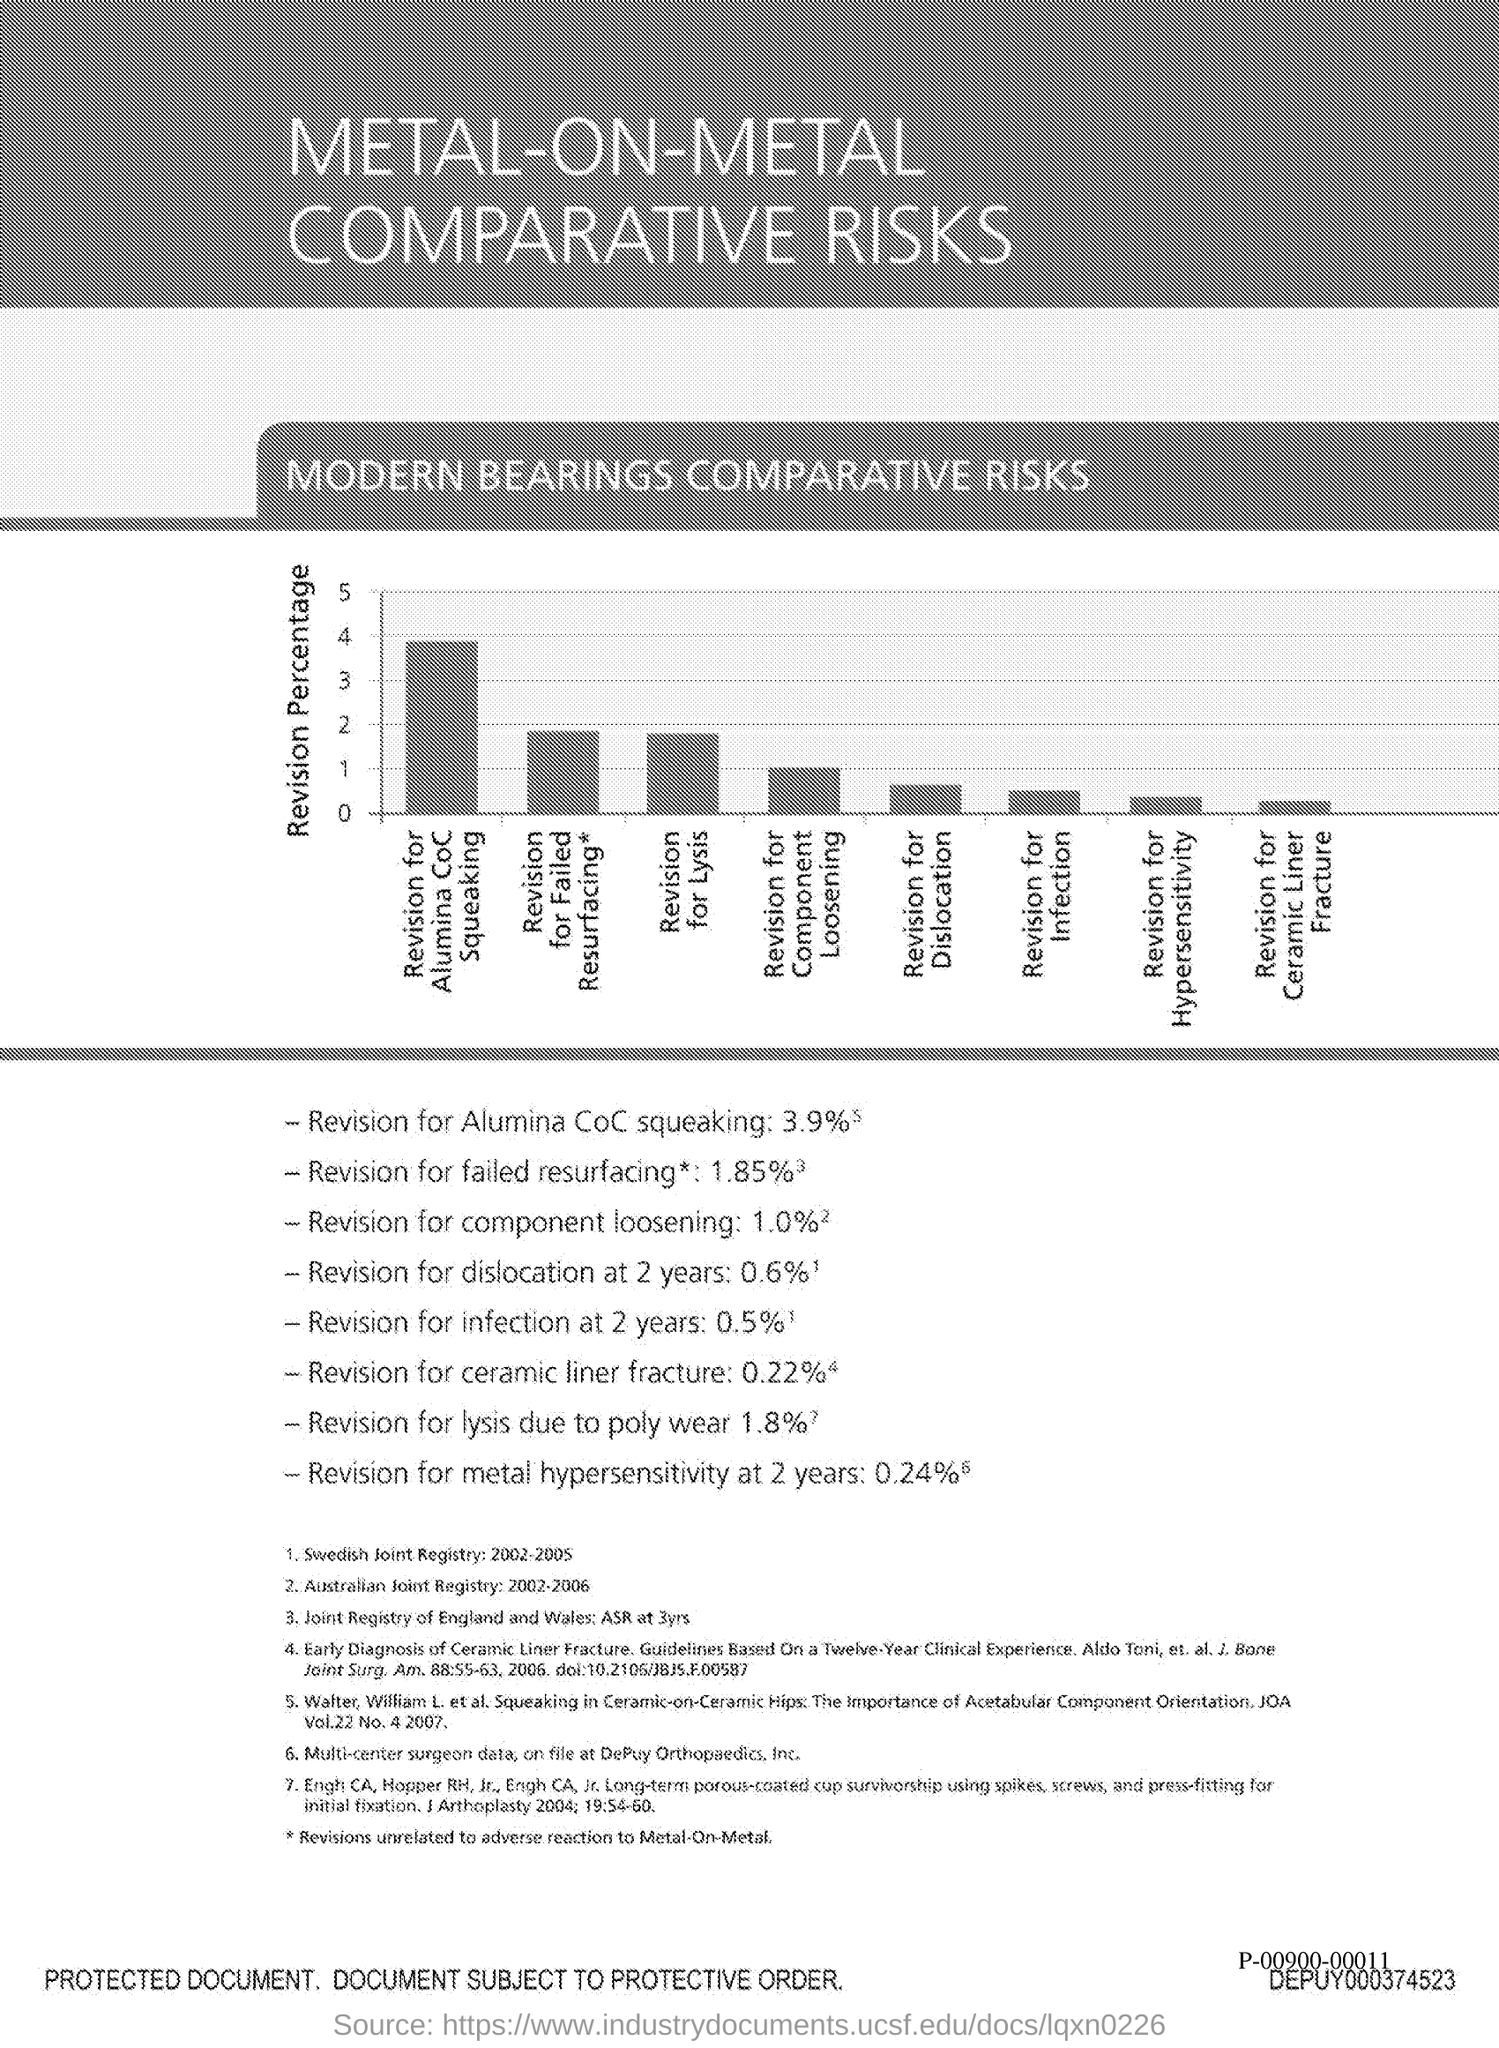What is the percentage of revision for Alumina CoC squeaking?
Provide a short and direct response. 3.9. What is the percentage of revision for failed resurfacing?
Your answer should be very brief. 1.85. What is the percentage of revision for component loosening?
Offer a very short reply. 1. What is the percentage of revision for dislocation at 2 years?
Keep it short and to the point. 0.6. What is the percentage of revision for infection at 2 years?
Give a very brief answer. 0.5. What is the percentage of revision for ceramic liner fracture?
Give a very brief answer. 0.22%. What is the percentage of revision for lysis due to poly wear?
Give a very brief answer. 1.8%. What is the percentage of revision for metal hypersensitivity at 2 years?
Offer a very short reply. 0.24. 